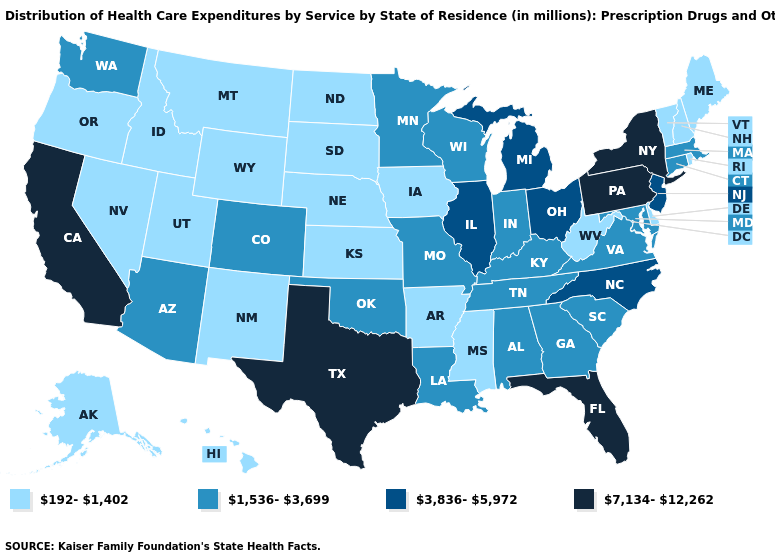Among the states that border Ohio , which have the highest value?
Answer briefly. Pennsylvania. What is the value of Utah?
Answer briefly. 192-1,402. How many symbols are there in the legend?
Answer briefly. 4. What is the lowest value in the USA?
Short answer required. 192-1,402. Does Wyoming have a lower value than Colorado?
Write a very short answer. Yes. Does South Carolina have the lowest value in the South?
Short answer required. No. Which states have the lowest value in the MidWest?
Give a very brief answer. Iowa, Kansas, Nebraska, North Dakota, South Dakota. Which states hav the highest value in the South?
Write a very short answer. Florida, Texas. What is the value of Oregon?
Concise answer only. 192-1,402. Is the legend a continuous bar?
Keep it brief. No. Which states have the lowest value in the South?
Answer briefly. Arkansas, Delaware, Mississippi, West Virginia. What is the value of California?
Quick response, please. 7,134-12,262. What is the highest value in the Northeast ?
Concise answer only. 7,134-12,262. Name the states that have a value in the range 192-1,402?
Write a very short answer. Alaska, Arkansas, Delaware, Hawaii, Idaho, Iowa, Kansas, Maine, Mississippi, Montana, Nebraska, Nevada, New Hampshire, New Mexico, North Dakota, Oregon, Rhode Island, South Dakota, Utah, Vermont, West Virginia, Wyoming. Which states hav the highest value in the West?
Concise answer only. California. 